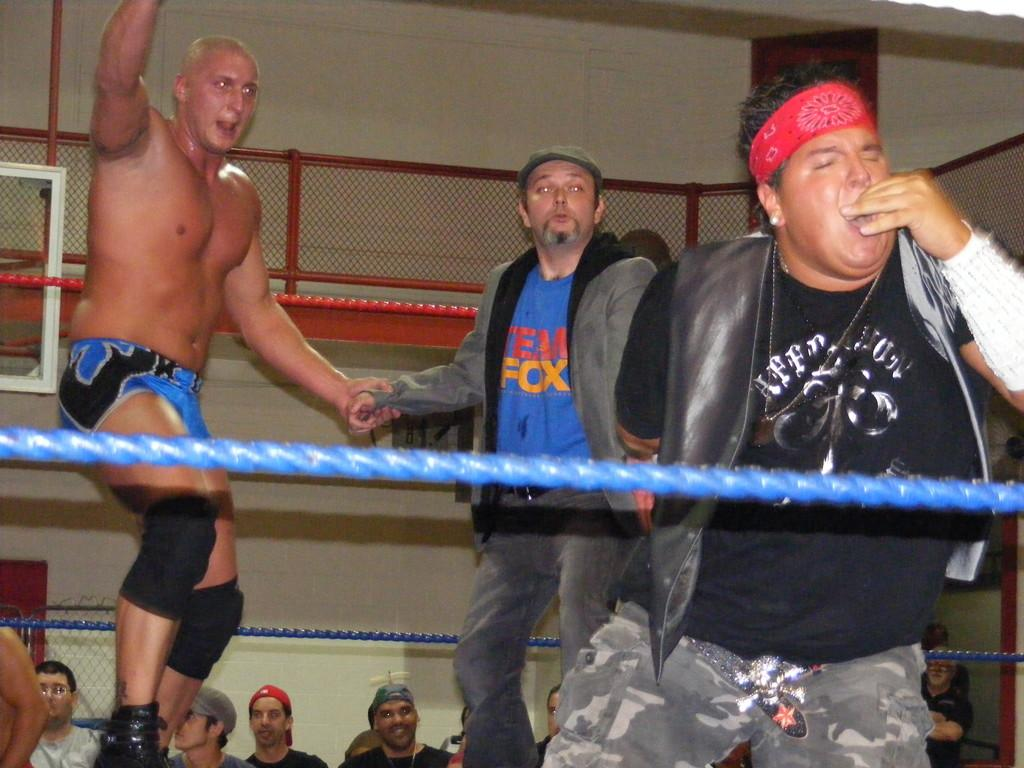<image>
Share a concise interpretation of the image provided. A guy in a Team Fox shirt shakes the hand of a wrestler in a ring as others watch. 